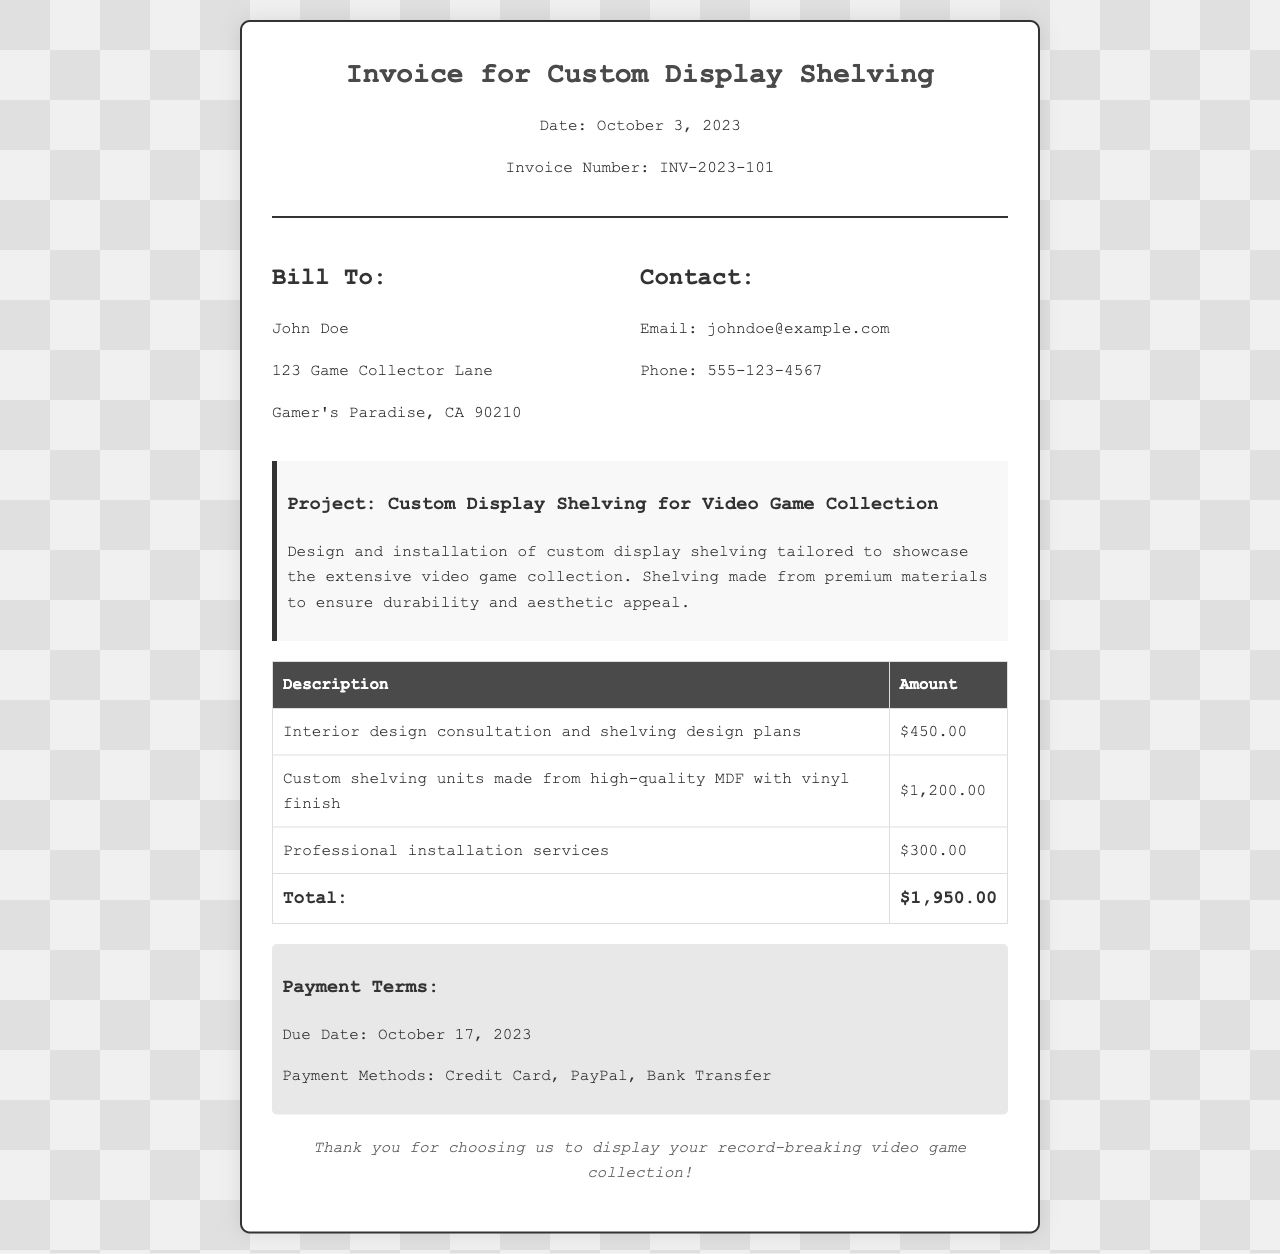What is the invoice date? The invoice date is mentioned in the header of the document.
Answer: October 3, 2023 Who is the invoice billed to? The billing section of the document lists the name of the customer.
Answer: John Doe What is the total amount due? The total amount due is calculated in the cost breakdown section of the invoice.
Answer: $1,950.00 When is the payment due? The payment terms section specifically states the due date for the payment.
Answer: October 17, 2023 What are the payment methods available? The payment methods are listed in the payment terms section of the document.
Answer: Credit Card, PayPal, Bank Transfer How much is charged for professional installation services? The cost breakdown table specifies the amount for this service.
Answer: $300.00 What type of material is used for the custom shelving units? The description in the cost breakdown table mentions the material used.
Answer: High-quality MDF with vinyl finish What is the purpose of this invoice? The description at the top defines the project for which the invoice is issued.
Answer: Custom Display Shelving for Video Game Collection What is the invoice number? The invoice number is located in the header section of the document.
Answer: INV-2023-101 